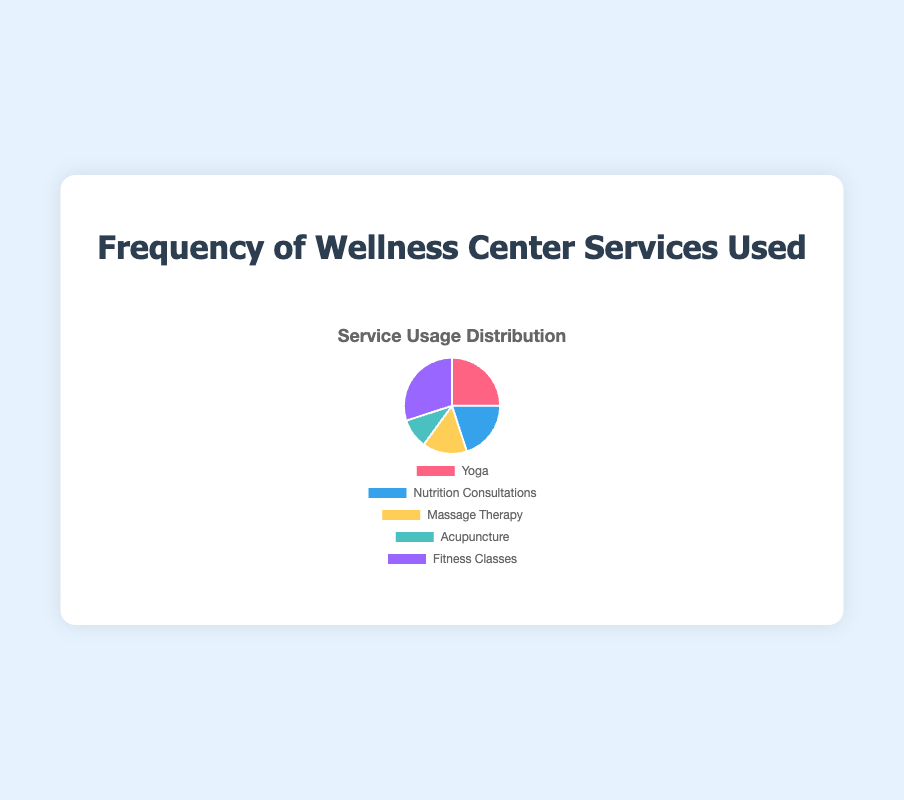What percentage of the services usage is for Yoga? Yoga has a usage frequency of 25 out of a total of 100 (25 + 20 + 15 + 10 + 30 = 100). The percentage is (25/100) * 100 = 25%.
Answer: 25% Which service is used the most frequently? The service with the highest usage frequency on the pie chart is Fitness Classes, with a frequency of 30.
Answer: Fitness Classes What is the combined percentage usage of Nutrition Consultations and Acupuncture? Nutrition Consultations have a usage frequency of 20 and Acupuncture has 10. Combined, they have 20 + 10 = 30. The percentage is (30/100) * 100 = 30%.
Answer: 30% How much greater is the usage frequency of Fitness Classes compared to Massage Therapy? Fitness Classes have a usage frequency of 30, and Massage Therapy has 15. The difference is 30 - 15 = 15.
Answer: 15 Which service is represented by the blue segment? The blue segment is labeled as Nutrition Consultations on the pie chart.
Answer: Nutrition Consultations What is the average usage frequency of all the services? The total usage frequency is 25 + 20 + 15 + 10 + 30 = 100. There are 5 services, so the average is 100 / 5 = 20.
Answer: 20 Do more people use Yoga or Acupuncture? The pie chart shows Yoga with a usage frequency of 25 and Acupuncture with 10. Yoga is more frequently used.
Answer: Yoga What is the sum of the usage frequencies of the top two most frequently used services? The most frequently used services are Fitness Classes (30) and Yoga (25). Their combined usage frequency is 30 + 25 = 55.
Answer: 55 Is there any service that has exactly the same percentage usage as another service? By looking at the frequencies and calculating percentages, no two services have the same percentage usage. Each service has a unique frequency and hence a unique percentage.
Answer: No Describe the segment for Massage Therapy. The segment for Massage Therapy is colored yellow and indicates a usage frequency of 15.
Answer: Yellow, 15 